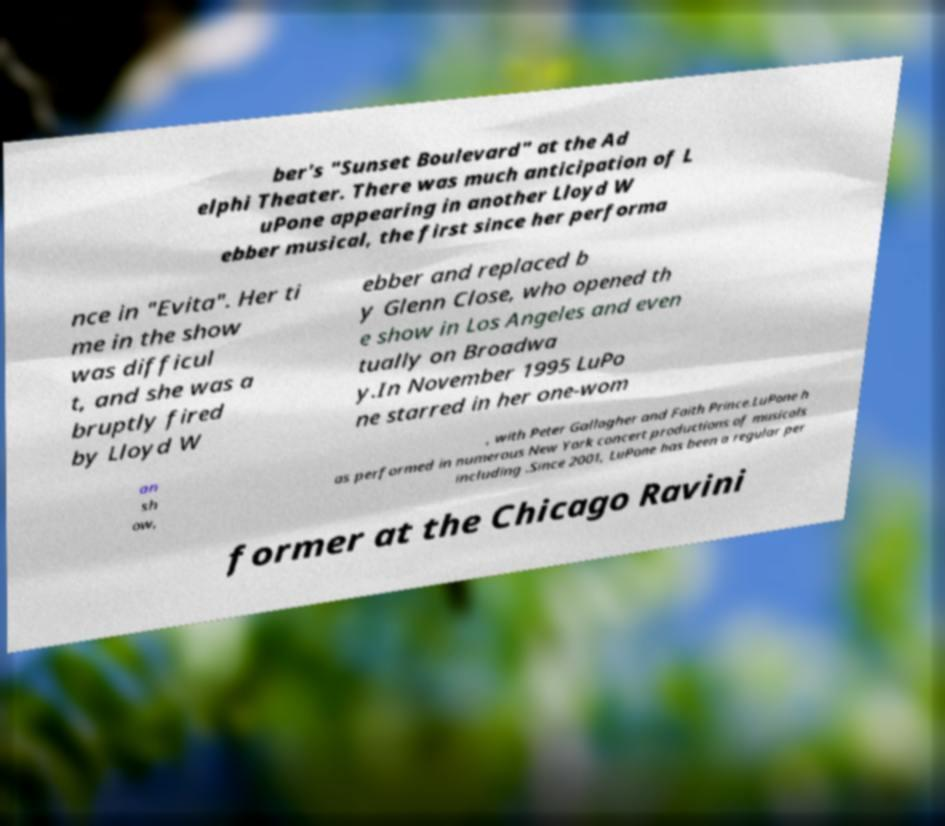Please identify and transcribe the text found in this image. ber's "Sunset Boulevard" at the Ad elphi Theater. There was much anticipation of L uPone appearing in another Lloyd W ebber musical, the first since her performa nce in "Evita". Her ti me in the show was difficul t, and she was a bruptly fired by Lloyd W ebber and replaced b y Glenn Close, who opened th e show in Los Angeles and even tually on Broadwa y.In November 1995 LuPo ne starred in her one-wom an sh ow, , with Peter Gallagher and Faith Prince.LuPone h as performed in numerous New York concert productions of musicals including .Since 2001, LuPone has been a regular per former at the Chicago Ravini 